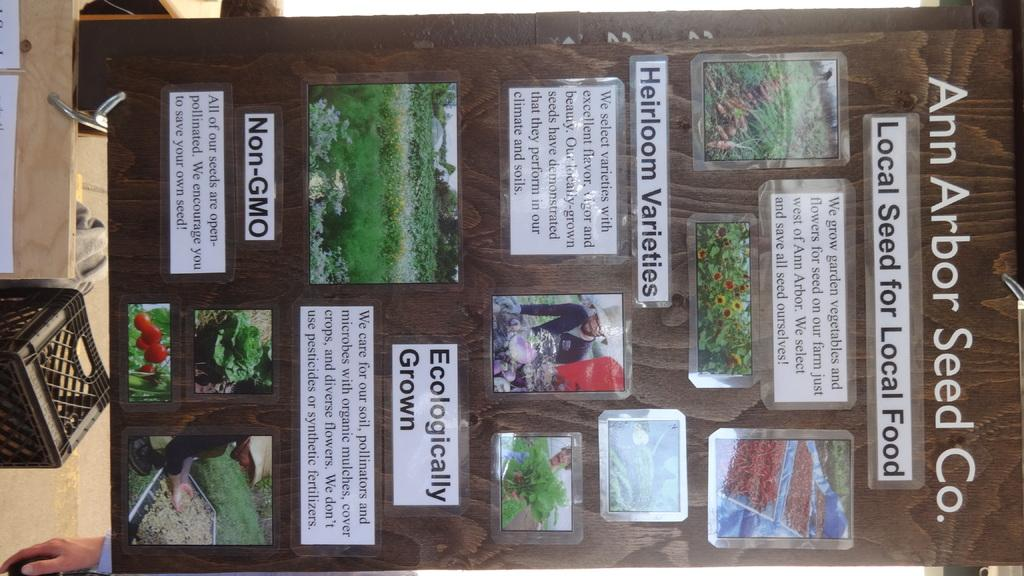<image>
Render a clear and concise summary of the photo. A board with information about the Ann Arbor Seed company has some information about heirloom varieties. 